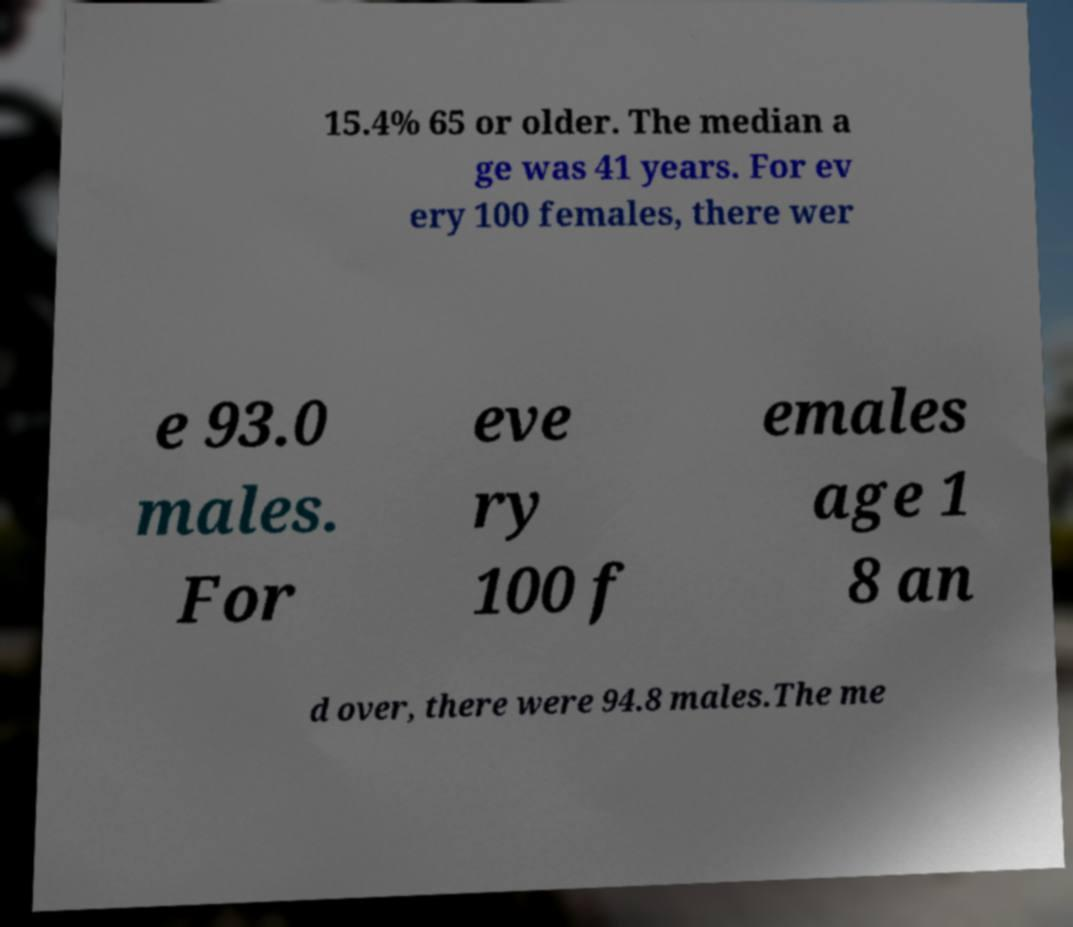Please identify and transcribe the text found in this image. 15.4% 65 or older. The median a ge was 41 years. For ev ery 100 females, there wer e 93.0 males. For eve ry 100 f emales age 1 8 an d over, there were 94.8 males.The me 